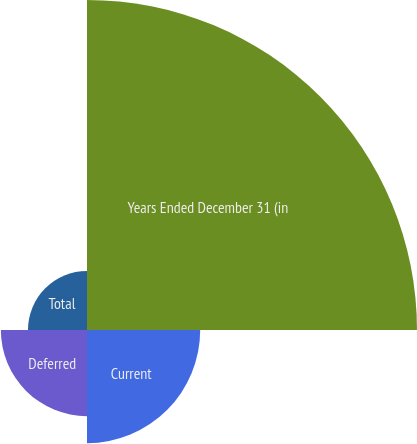Convert chart. <chart><loc_0><loc_0><loc_500><loc_500><pie_chart><fcel>Years Ended December 31 (in<fcel>Current<fcel>Deferred<fcel>Total<nl><fcel>56.09%<fcel>19.24%<fcel>14.64%<fcel>10.03%<nl></chart> 